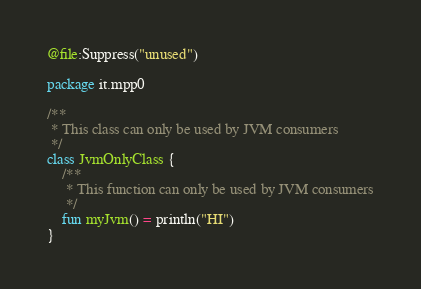Convert code to text. <code><loc_0><loc_0><loc_500><loc_500><_Kotlin_>@file:Suppress("unused")

package it.mpp0

/**
 * This class can only be used by JVM consumers
 */
class JvmOnlyClass {
    /**
     * This function can only be used by JVM consumers
     */
    fun myJvm() = println("HI")
}
</code> 